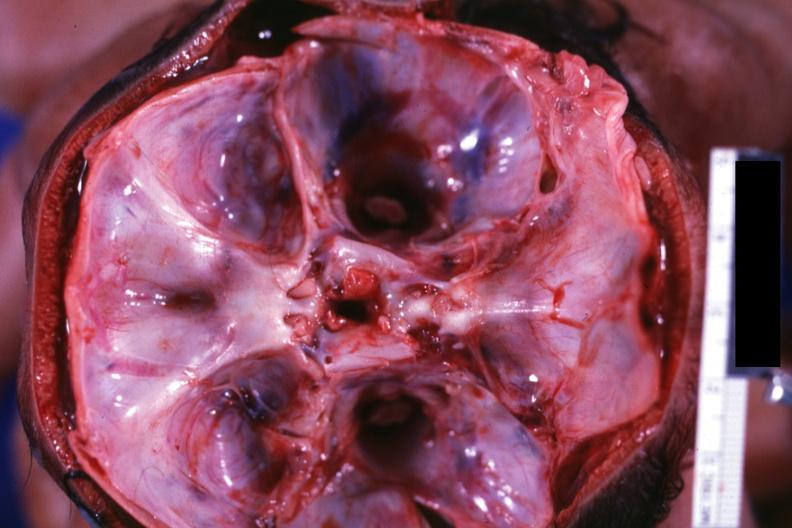what is present?
Answer the question using a single word or phrase. Conjoined twins cephalothoracopagus janiceps 